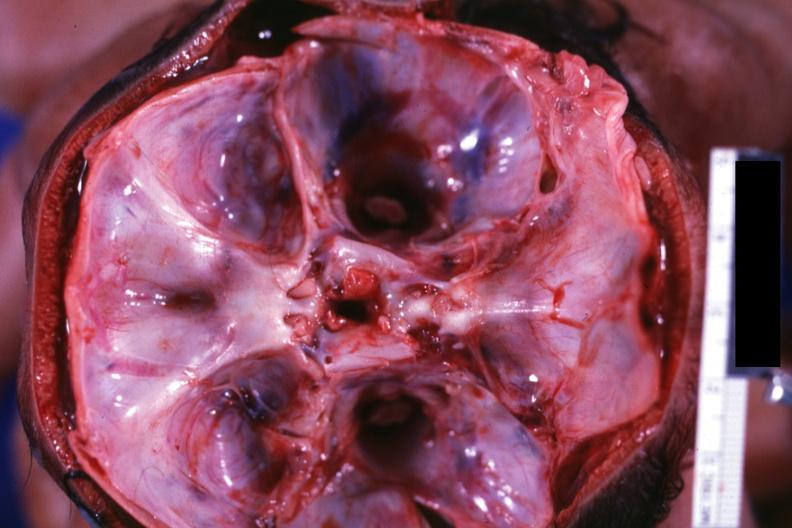what is present?
Answer the question using a single word or phrase. Conjoined twins cephalothoracopagus janiceps 